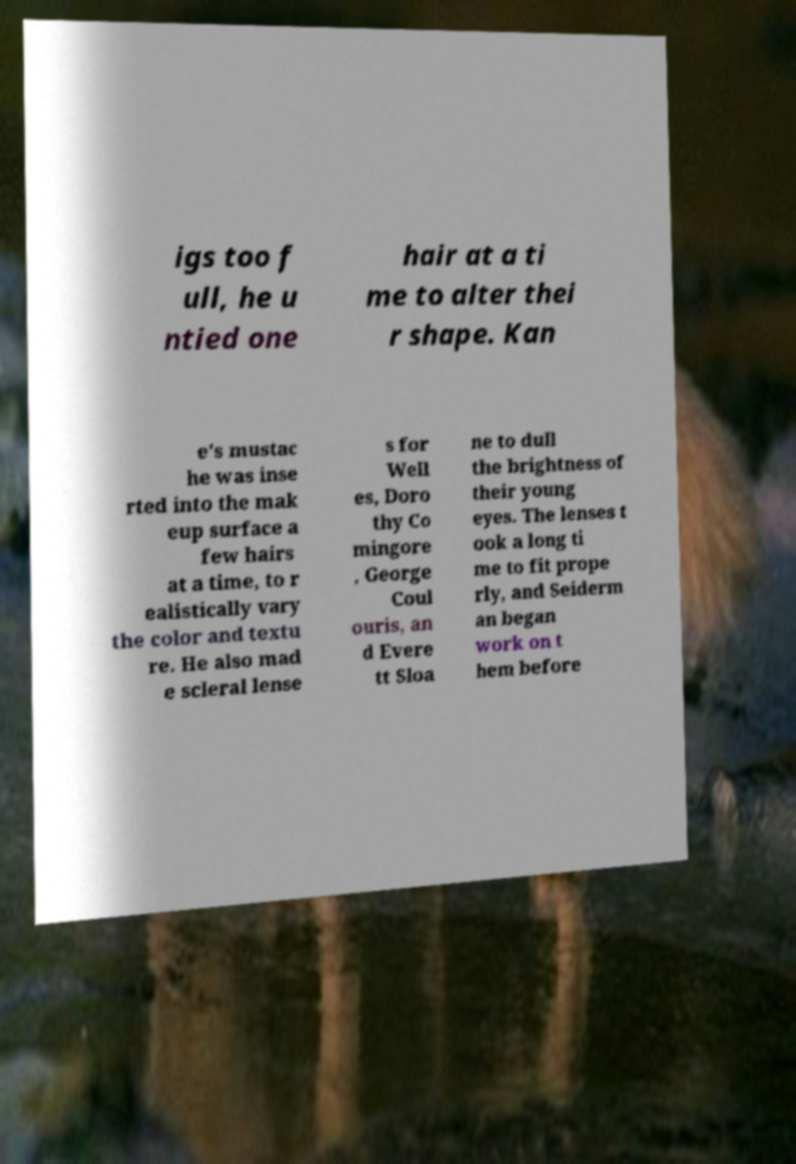What messages or text are displayed in this image? I need them in a readable, typed format. igs too f ull, he u ntied one hair at a ti me to alter thei r shape. Kan e's mustac he was inse rted into the mak eup surface a few hairs at a time, to r ealistically vary the color and textu re. He also mad e scleral lense s for Well es, Doro thy Co mingore , George Coul ouris, an d Evere tt Sloa ne to dull the brightness of their young eyes. The lenses t ook a long ti me to fit prope rly, and Seiderm an began work on t hem before 